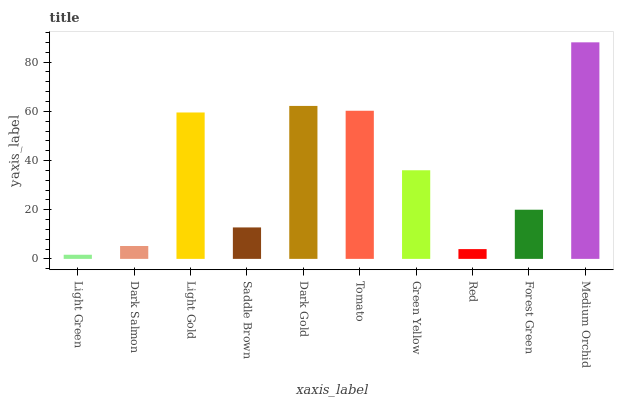Is Light Green the minimum?
Answer yes or no. Yes. Is Medium Orchid the maximum?
Answer yes or no. Yes. Is Dark Salmon the minimum?
Answer yes or no. No. Is Dark Salmon the maximum?
Answer yes or no. No. Is Dark Salmon greater than Light Green?
Answer yes or no. Yes. Is Light Green less than Dark Salmon?
Answer yes or no. Yes. Is Light Green greater than Dark Salmon?
Answer yes or no. No. Is Dark Salmon less than Light Green?
Answer yes or no. No. Is Green Yellow the high median?
Answer yes or no. Yes. Is Forest Green the low median?
Answer yes or no. Yes. Is Forest Green the high median?
Answer yes or no. No. Is Dark Salmon the low median?
Answer yes or no. No. 